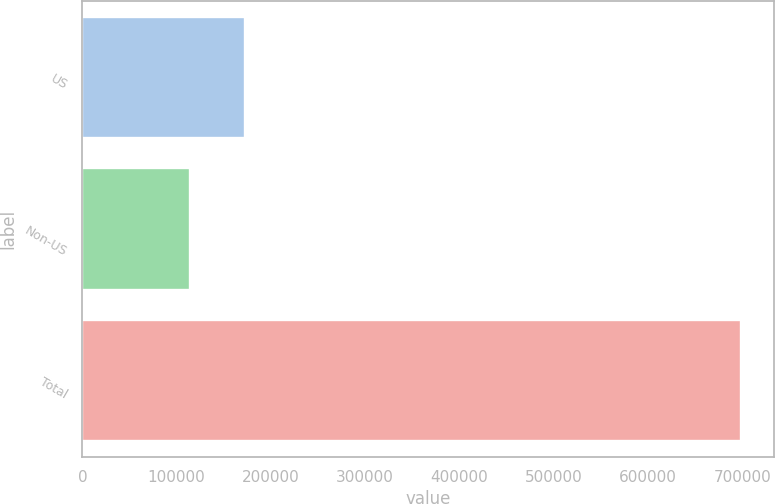Convert chart. <chart><loc_0><loc_0><loc_500><loc_500><bar_chart><fcel>US<fcel>Non-US<fcel>Total<nl><fcel>172871<fcel>114445<fcel>698704<nl></chart> 